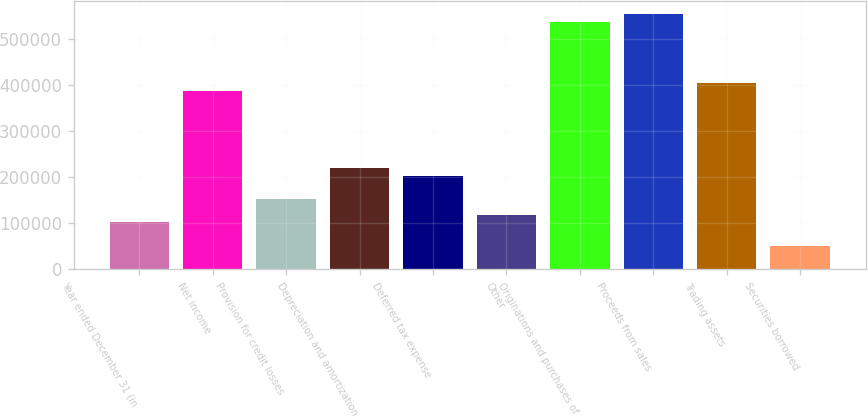Convert chart. <chart><loc_0><loc_0><loc_500><loc_500><bar_chart><fcel>Year ended December 31 (in<fcel>Net income<fcel>Provision for credit losses<fcel>Depreciation and amortization<fcel>Deferred tax expense<fcel>Other<fcel>Originations and purchases of<fcel>Proceeds from sales<fcel>Trading assets<fcel>Securities borrowed<nl><fcel>101181<fcel>386972<fcel>151615<fcel>218860<fcel>202048<fcel>117992<fcel>538272<fcel>555084<fcel>403783<fcel>50747.6<nl></chart> 